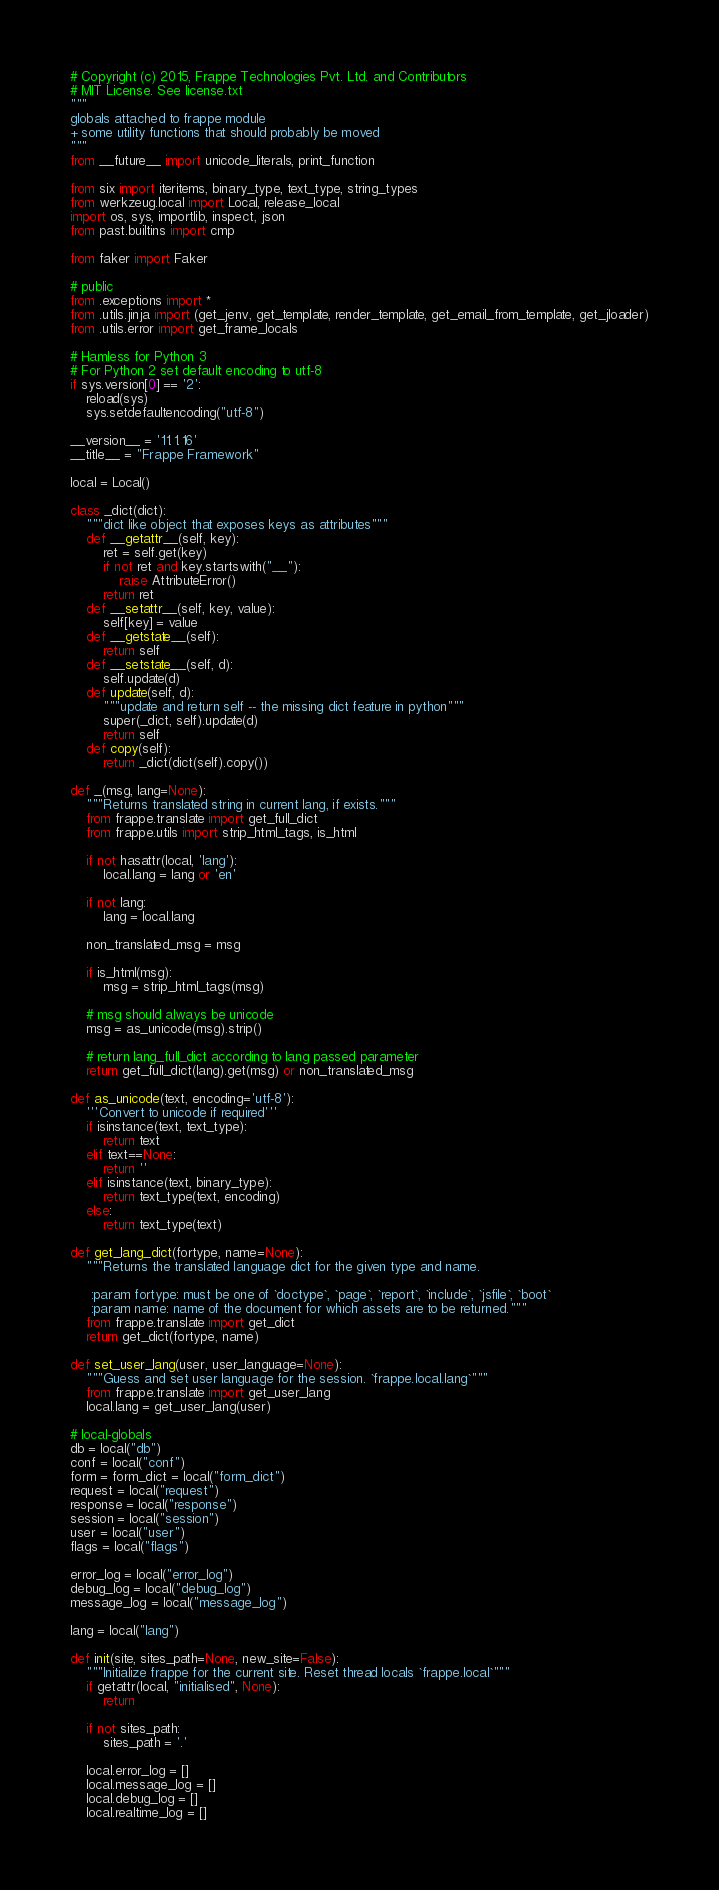Convert code to text. <code><loc_0><loc_0><loc_500><loc_500><_Python_># Copyright (c) 2015, Frappe Technologies Pvt. Ltd. and Contributors
# MIT License. See license.txt
"""
globals attached to frappe module
+ some utility functions that should probably be moved
"""
from __future__ import unicode_literals, print_function

from six import iteritems, binary_type, text_type, string_types
from werkzeug.local import Local, release_local
import os, sys, importlib, inspect, json
from past.builtins import cmp

from faker import Faker

# public
from .exceptions import *
from .utils.jinja import (get_jenv, get_template, render_template, get_email_from_template, get_jloader)
from .utils.error import get_frame_locals

# Hamless for Python 3
# For Python 2 set default encoding to utf-8
if sys.version[0] == '2':
	reload(sys)
	sys.setdefaultencoding("utf-8")

__version__ = '11.1.16'
__title__ = "Frappe Framework"

local = Local()

class _dict(dict):
	"""dict like object that exposes keys as attributes"""
	def __getattr__(self, key):
		ret = self.get(key)
		if not ret and key.startswith("__"):
			raise AttributeError()
		return ret
	def __setattr__(self, key, value):
		self[key] = value
	def __getstate__(self):
		return self
	def __setstate__(self, d):
		self.update(d)
	def update(self, d):
		"""update and return self -- the missing dict feature in python"""
		super(_dict, self).update(d)
		return self
	def copy(self):
		return _dict(dict(self).copy())

def _(msg, lang=None):
	"""Returns translated string in current lang, if exists."""
	from frappe.translate import get_full_dict
	from frappe.utils import strip_html_tags, is_html

	if not hasattr(local, 'lang'):
		local.lang = lang or 'en'

	if not lang:
		lang = local.lang

	non_translated_msg = msg

	if is_html(msg):
		msg = strip_html_tags(msg)

	# msg should always be unicode
	msg = as_unicode(msg).strip()

	# return lang_full_dict according to lang passed parameter
	return get_full_dict(lang).get(msg) or non_translated_msg

def as_unicode(text, encoding='utf-8'):
	'''Convert to unicode if required'''
	if isinstance(text, text_type):
		return text
	elif text==None:
		return ''
	elif isinstance(text, binary_type):
		return text_type(text, encoding)
	else:
		return text_type(text)

def get_lang_dict(fortype, name=None):
	"""Returns the translated language dict for the given type and name.

	 :param fortype: must be one of `doctype`, `page`, `report`, `include`, `jsfile`, `boot`
	 :param name: name of the document for which assets are to be returned."""
	from frappe.translate import get_dict
	return get_dict(fortype, name)

def set_user_lang(user, user_language=None):
	"""Guess and set user language for the session. `frappe.local.lang`"""
	from frappe.translate import get_user_lang
	local.lang = get_user_lang(user)

# local-globals
db = local("db")
conf = local("conf")
form = form_dict = local("form_dict")
request = local("request")
response = local("response")
session = local("session")
user = local("user")
flags = local("flags")

error_log = local("error_log")
debug_log = local("debug_log")
message_log = local("message_log")

lang = local("lang")

def init(site, sites_path=None, new_site=False):
	"""Initialize frappe for the current site. Reset thread locals `frappe.local`"""
	if getattr(local, "initialised", None):
		return

	if not sites_path:
		sites_path = '.'

	local.error_log = []
	local.message_log = []
	local.debug_log = []
	local.realtime_log = []</code> 